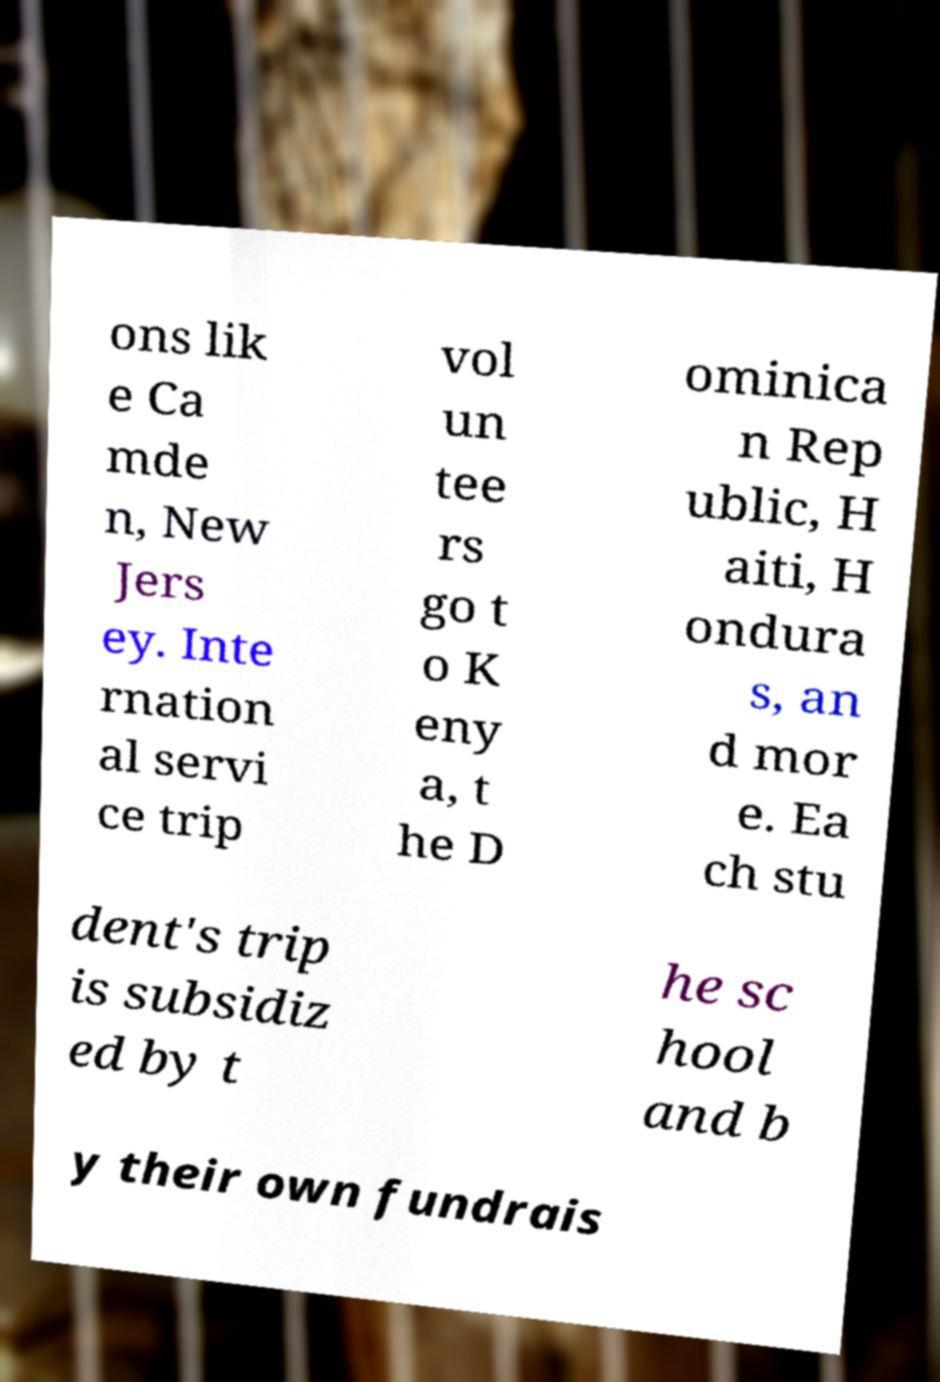Can you accurately transcribe the text from the provided image for me? ons lik e Ca mde n, New Jers ey. Inte rnation al servi ce trip vol un tee rs go t o K eny a, t he D ominica n Rep ublic, H aiti, H ondura s, an d mor e. Ea ch stu dent's trip is subsidiz ed by t he sc hool and b y their own fundrais 